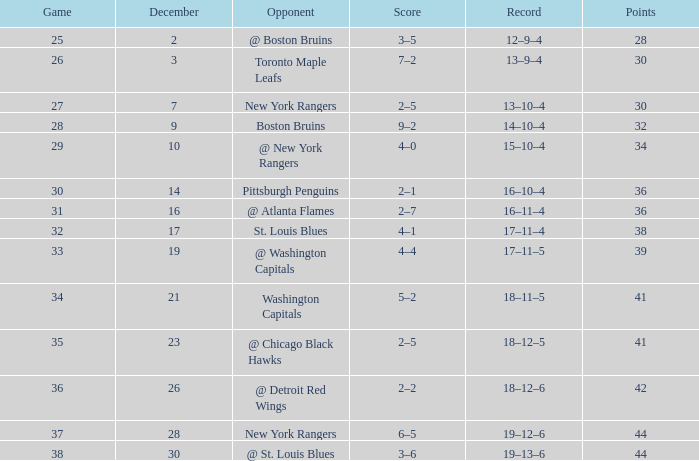Which game has a record of 14-10-4 and points less than 32? None. 